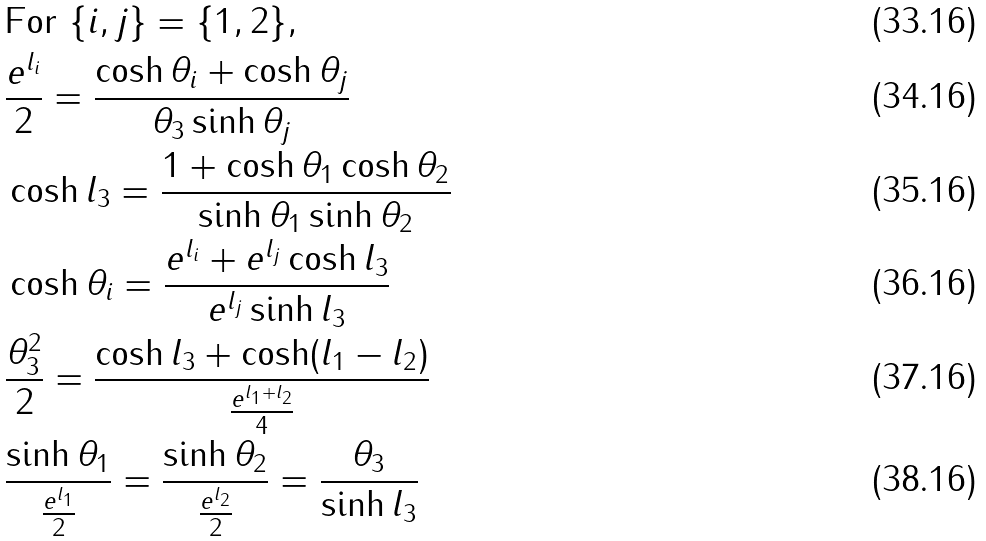<formula> <loc_0><loc_0><loc_500><loc_500>& \text {For} \ \{ i , j \} = \{ 1 , 2 \} , & \\ & \frac { e ^ { l _ { i } } } 2 = \frac { \cosh \theta _ { i } + \cosh \theta _ { j } } { \theta _ { 3 } \sinh \theta _ { j } } & \\ & \cosh l _ { 3 } = \frac { 1 + \cosh \theta _ { 1 } \cosh \theta _ { 2 } } { \sinh \theta _ { 1 } \sinh \theta _ { 2 } } & \\ & \cosh \theta _ { i } = \frac { e ^ { l _ { i } } + e ^ { l _ { j } } \cosh l _ { 3 } } { e ^ { l _ { j } } \sinh l _ { 3 } } & \\ & \frac { \theta _ { 3 } ^ { 2 } } { 2 } = \frac { \cosh l _ { 3 } + \cosh ( l _ { 1 } - l _ { 2 } ) } { \frac { e ^ { l _ { 1 } + l _ { 2 } } } 4 } & \\ & \frac { \sinh \theta _ { 1 } } { \frac { e ^ { l _ { 1 } } } 2 } = \frac { \sinh \theta _ { 2 } } { \frac { e ^ { l _ { 2 } } } 2 } = \frac { \theta _ { 3 } } { \sinh l _ { 3 } } &</formula> 